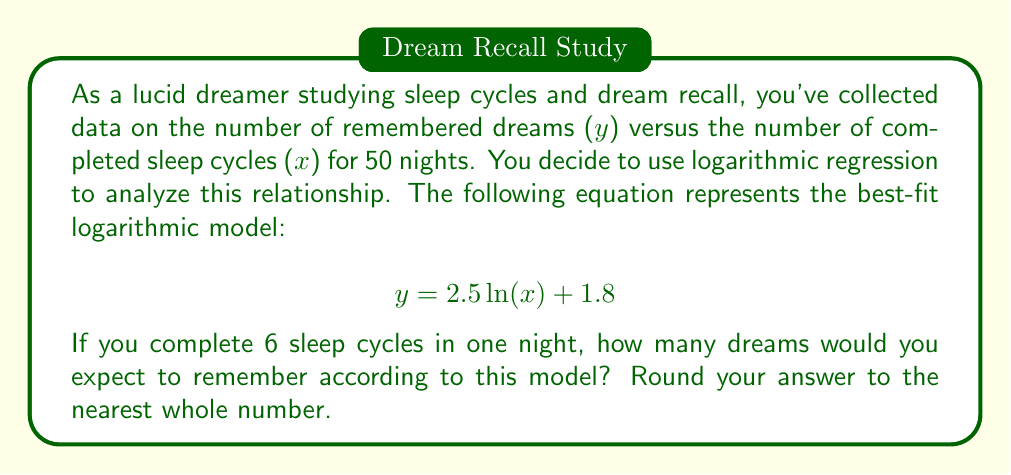Teach me how to tackle this problem. To solve this problem, we need to use the given logarithmic regression equation and substitute the value of x with 6 (the number of completed sleep cycles).

The logarithmic regression equation is:
$$ y = 2.5 \ln(x) + 1.8 $$

Where:
- y is the number of remembered dreams
- x is the number of completed sleep cycles
- ln is the natural logarithm

Steps to solve:

1. Substitute x = 6 into the equation:
   $$ y = 2.5 \ln(6) + 1.8 $$

2. Calculate the natural logarithm of 6:
   $\ln(6) \approx 1.7917595$

3. Multiply 2.5 by the result of step 2:
   $$ 2.5 \times 1.7917595 \approx 4.4793988 $$

4. Add 1.8 to the result of step 3:
   $$ 4.4793988 + 1.8 = 6.2793988 $$

5. Round the result to the nearest whole number:
   $$ 6.2793988 \approx 6 $$

Therefore, according to this logarithmic regression model, you would expect to remember approximately 6 dreams after completing 6 sleep cycles.
Answer: 6 dreams 